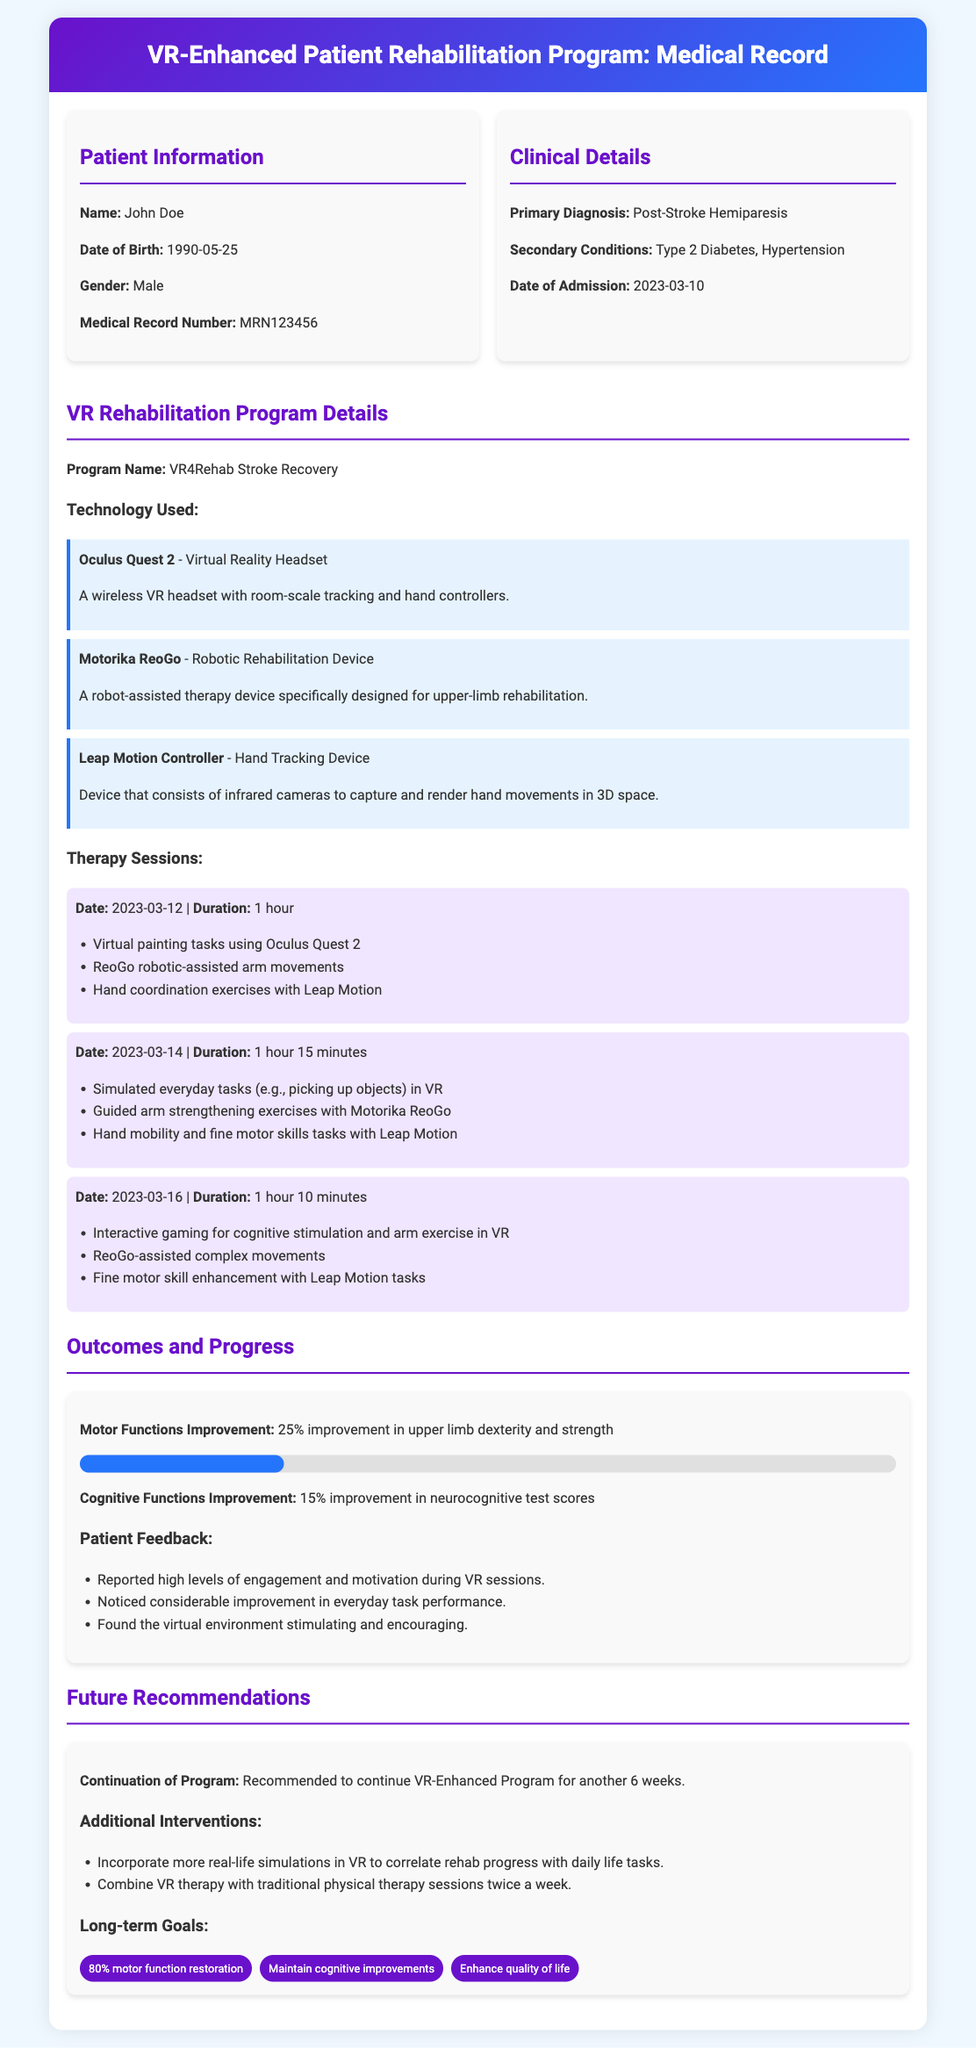What is the patient's name? The patient's name is provided in the Patient Information section of the document.
Answer: John Doe What is the primary diagnosis? The primary diagnosis is mentioned in the Clinical Details section.
Answer: Post-Stroke Hemiparesis What is the program name? The program name can be found under VR Rehabilitation Program Details.
Answer: VR4Rehab Stroke Recovery What technology is used for hand tracking? The technology used for hand tracking is specified in the Technology Used section.
Answer: Leap Motion Controller How much improvement was seen in cognitive functions? The improvement rate for cognitive functions is stated in the Outcomes and Progress section.
Answer: 15% What is the recommended duration for continuing the program? The recommendation for program duration is mentioned under Future Recommendations.
Answer: Another 6 weeks What device is used for robotic rehabilitation? The device used for robotic rehabilitation is listed under VR Rehabilitation Program Details.
Answer: Motorika ReoGo What percentage of motor function restoration is targeted as a long-term goal? The long-term goal percentage is provided in the Future Recommendations section.
Answer: 80% 